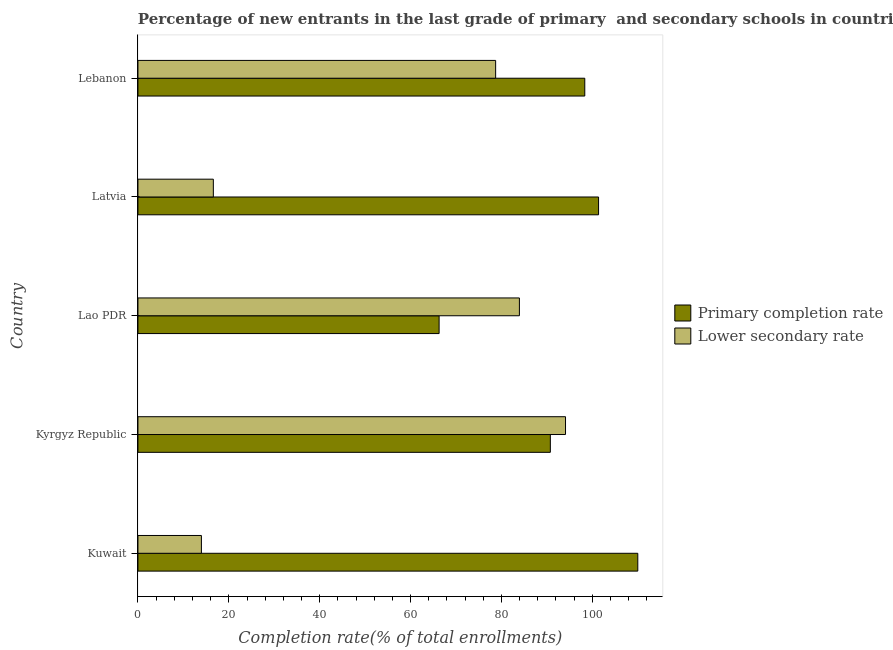How many different coloured bars are there?
Offer a terse response. 2. How many bars are there on the 3rd tick from the top?
Make the answer very short. 2. What is the label of the 2nd group of bars from the top?
Your response must be concise. Latvia. In how many cases, is the number of bars for a given country not equal to the number of legend labels?
Provide a short and direct response. 0. What is the completion rate in primary schools in Latvia?
Ensure brevity in your answer.  101.39. Across all countries, what is the maximum completion rate in primary schools?
Provide a short and direct response. 110.02. Across all countries, what is the minimum completion rate in secondary schools?
Provide a short and direct response. 13.96. In which country was the completion rate in primary schools maximum?
Ensure brevity in your answer.  Kuwait. In which country was the completion rate in primary schools minimum?
Your response must be concise. Lao PDR. What is the total completion rate in secondary schools in the graph?
Give a very brief answer. 287.36. What is the difference between the completion rate in primary schools in Lao PDR and that in Lebanon?
Your answer should be very brief. -32.07. What is the difference between the completion rate in primary schools in Lebanon and the completion rate in secondary schools in Lao PDR?
Provide a succinct answer. 14.39. What is the average completion rate in secondary schools per country?
Your response must be concise. 57.47. What is the difference between the completion rate in secondary schools and completion rate in primary schools in Kyrgyz Republic?
Give a very brief answer. 3.34. What is the ratio of the completion rate in secondary schools in Kuwait to that in Lao PDR?
Provide a succinct answer. 0.17. Is the completion rate in primary schools in Kyrgyz Republic less than that in Lao PDR?
Keep it short and to the point. No. Is the difference between the completion rate in secondary schools in Kuwait and Lebanon greater than the difference between the completion rate in primary schools in Kuwait and Lebanon?
Offer a terse response. No. What is the difference between the highest and the second highest completion rate in primary schools?
Provide a succinct answer. 8.63. What is the difference between the highest and the lowest completion rate in secondary schools?
Keep it short and to the point. 80.15. In how many countries, is the completion rate in primary schools greater than the average completion rate in primary schools taken over all countries?
Your answer should be very brief. 3. What does the 2nd bar from the top in Kuwait represents?
Your answer should be very brief. Primary completion rate. What does the 1st bar from the bottom in Latvia represents?
Give a very brief answer. Primary completion rate. Are the values on the major ticks of X-axis written in scientific E-notation?
Ensure brevity in your answer.  No. Where does the legend appear in the graph?
Ensure brevity in your answer.  Center right. How many legend labels are there?
Your answer should be very brief. 2. What is the title of the graph?
Offer a terse response. Percentage of new entrants in the last grade of primary  and secondary schools in countries. Does "Highest 10% of population" appear as one of the legend labels in the graph?
Your answer should be very brief. No. What is the label or title of the X-axis?
Your answer should be compact. Completion rate(% of total enrollments). What is the label or title of the Y-axis?
Ensure brevity in your answer.  Country. What is the Completion rate(% of total enrollments) in Primary completion rate in Kuwait?
Your answer should be very brief. 110.02. What is the Completion rate(% of total enrollments) in Lower secondary rate in Kuwait?
Your response must be concise. 13.96. What is the Completion rate(% of total enrollments) in Primary completion rate in Kyrgyz Republic?
Keep it short and to the point. 90.77. What is the Completion rate(% of total enrollments) of Lower secondary rate in Kyrgyz Republic?
Keep it short and to the point. 94.11. What is the Completion rate(% of total enrollments) of Primary completion rate in Lao PDR?
Your answer should be compact. 66.29. What is the Completion rate(% of total enrollments) of Lower secondary rate in Lao PDR?
Provide a short and direct response. 83.96. What is the Completion rate(% of total enrollments) in Primary completion rate in Latvia?
Offer a very short reply. 101.39. What is the Completion rate(% of total enrollments) of Lower secondary rate in Latvia?
Your answer should be very brief. 16.59. What is the Completion rate(% of total enrollments) of Primary completion rate in Lebanon?
Offer a very short reply. 98.35. What is the Completion rate(% of total enrollments) of Lower secondary rate in Lebanon?
Keep it short and to the point. 78.73. Across all countries, what is the maximum Completion rate(% of total enrollments) in Primary completion rate?
Offer a terse response. 110.02. Across all countries, what is the maximum Completion rate(% of total enrollments) of Lower secondary rate?
Provide a succinct answer. 94.11. Across all countries, what is the minimum Completion rate(% of total enrollments) of Primary completion rate?
Make the answer very short. 66.29. Across all countries, what is the minimum Completion rate(% of total enrollments) in Lower secondary rate?
Ensure brevity in your answer.  13.96. What is the total Completion rate(% of total enrollments) in Primary completion rate in the graph?
Ensure brevity in your answer.  466.81. What is the total Completion rate(% of total enrollments) in Lower secondary rate in the graph?
Keep it short and to the point. 287.36. What is the difference between the Completion rate(% of total enrollments) in Primary completion rate in Kuwait and that in Kyrgyz Republic?
Your answer should be compact. 19.25. What is the difference between the Completion rate(% of total enrollments) of Lower secondary rate in Kuwait and that in Kyrgyz Republic?
Provide a succinct answer. -80.15. What is the difference between the Completion rate(% of total enrollments) of Primary completion rate in Kuwait and that in Lao PDR?
Offer a terse response. 43.73. What is the difference between the Completion rate(% of total enrollments) in Lower secondary rate in Kuwait and that in Lao PDR?
Provide a short and direct response. -70. What is the difference between the Completion rate(% of total enrollments) of Primary completion rate in Kuwait and that in Latvia?
Give a very brief answer. 8.63. What is the difference between the Completion rate(% of total enrollments) in Lower secondary rate in Kuwait and that in Latvia?
Offer a terse response. -2.63. What is the difference between the Completion rate(% of total enrollments) in Primary completion rate in Kuwait and that in Lebanon?
Your answer should be very brief. 11.67. What is the difference between the Completion rate(% of total enrollments) in Lower secondary rate in Kuwait and that in Lebanon?
Provide a succinct answer. -64.76. What is the difference between the Completion rate(% of total enrollments) in Primary completion rate in Kyrgyz Republic and that in Lao PDR?
Your answer should be compact. 24.48. What is the difference between the Completion rate(% of total enrollments) in Lower secondary rate in Kyrgyz Republic and that in Lao PDR?
Your response must be concise. 10.15. What is the difference between the Completion rate(% of total enrollments) in Primary completion rate in Kyrgyz Republic and that in Latvia?
Give a very brief answer. -10.62. What is the difference between the Completion rate(% of total enrollments) of Lower secondary rate in Kyrgyz Republic and that in Latvia?
Provide a short and direct response. 77.52. What is the difference between the Completion rate(% of total enrollments) in Primary completion rate in Kyrgyz Republic and that in Lebanon?
Provide a short and direct response. -7.58. What is the difference between the Completion rate(% of total enrollments) of Lower secondary rate in Kyrgyz Republic and that in Lebanon?
Keep it short and to the point. 15.38. What is the difference between the Completion rate(% of total enrollments) of Primary completion rate in Lao PDR and that in Latvia?
Your answer should be very brief. -35.1. What is the difference between the Completion rate(% of total enrollments) of Lower secondary rate in Lao PDR and that in Latvia?
Make the answer very short. 67.37. What is the difference between the Completion rate(% of total enrollments) of Primary completion rate in Lao PDR and that in Lebanon?
Keep it short and to the point. -32.07. What is the difference between the Completion rate(% of total enrollments) in Lower secondary rate in Lao PDR and that in Lebanon?
Your response must be concise. 5.23. What is the difference between the Completion rate(% of total enrollments) of Primary completion rate in Latvia and that in Lebanon?
Offer a very short reply. 3.03. What is the difference between the Completion rate(% of total enrollments) in Lower secondary rate in Latvia and that in Lebanon?
Provide a short and direct response. -62.13. What is the difference between the Completion rate(% of total enrollments) of Primary completion rate in Kuwait and the Completion rate(% of total enrollments) of Lower secondary rate in Kyrgyz Republic?
Your answer should be very brief. 15.91. What is the difference between the Completion rate(% of total enrollments) in Primary completion rate in Kuwait and the Completion rate(% of total enrollments) in Lower secondary rate in Lao PDR?
Make the answer very short. 26.06. What is the difference between the Completion rate(% of total enrollments) in Primary completion rate in Kuwait and the Completion rate(% of total enrollments) in Lower secondary rate in Latvia?
Keep it short and to the point. 93.43. What is the difference between the Completion rate(% of total enrollments) in Primary completion rate in Kuwait and the Completion rate(% of total enrollments) in Lower secondary rate in Lebanon?
Provide a succinct answer. 31.29. What is the difference between the Completion rate(% of total enrollments) in Primary completion rate in Kyrgyz Republic and the Completion rate(% of total enrollments) in Lower secondary rate in Lao PDR?
Provide a short and direct response. 6.81. What is the difference between the Completion rate(% of total enrollments) of Primary completion rate in Kyrgyz Republic and the Completion rate(% of total enrollments) of Lower secondary rate in Latvia?
Keep it short and to the point. 74.18. What is the difference between the Completion rate(% of total enrollments) of Primary completion rate in Kyrgyz Republic and the Completion rate(% of total enrollments) of Lower secondary rate in Lebanon?
Offer a very short reply. 12.04. What is the difference between the Completion rate(% of total enrollments) of Primary completion rate in Lao PDR and the Completion rate(% of total enrollments) of Lower secondary rate in Latvia?
Your response must be concise. 49.69. What is the difference between the Completion rate(% of total enrollments) in Primary completion rate in Lao PDR and the Completion rate(% of total enrollments) in Lower secondary rate in Lebanon?
Keep it short and to the point. -12.44. What is the difference between the Completion rate(% of total enrollments) of Primary completion rate in Latvia and the Completion rate(% of total enrollments) of Lower secondary rate in Lebanon?
Offer a terse response. 22.66. What is the average Completion rate(% of total enrollments) of Primary completion rate per country?
Offer a very short reply. 93.36. What is the average Completion rate(% of total enrollments) in Lower secondary rate per country?
Give a very brief answer. 57.47. What is the difference between the Completion rate(% of total enrollments) in Primary completion rate and Completion rate(% of total enrollments) in Lower secondary rate in Kuwait?
Provide a succinct answer. 96.05. What is the difference between the Completion rate(% of total enrollments) of Primary completion rate and Completion rate(% of total enrollments) of Lower secondary rate in Kyrgyz Republic?
Your answer should be compact. -3.34. What is the difference between the Completion rate(% of total enrollments) of Primary completion rate and Completion rate(% of total enrollments) of Lower secondary rate in Lao PDR?
Your response must be concise. -17.68. What is the difference between the Completion rate(% of total enrollments) of Primary completion rate and Completion rate(% of total enrollments) of Lower secondary rate in Latvia?
Your answer should be very brief. 84.79. What is the difference between the Completion rate(% of total enrollments) of Primary completion rate and Completion rate(% of total enrollments) of Lower secondary rate in Lebanon?
Ensure brevity in your answer.  19.62. What is the ratio of the Completion rate(% of total enrollments) of Primary completion rate in Kuwait to that in Kyrgyz Republic?
Provide a short and direct response. 1.21. What is the ratio of the Completion rate(% of total enrollments) in Lower secondary rate in Kuwait to that in Kyrgyz Republic?
Make the answer very short. 0.15. What is the ratio of the Completion rate(% of total enrollments) in Primary completion rate in Kuwait to that in Lao PDR?
Make the answer very short. 1.66. What is the ratio of the Completion rate(% of total enrollments) in Lower secondary rate in Kuwait to that in Lao PDR?
Ensure brevity in your answer.  0.17. What is the ratio of the Completion rate(% of total enrollments) in Primary completion rate in Kuwait to that in Latvia?
Make the answer very short. 1.09. What is the ratio of the Completion rate(% of total enrollments) in Lower secondary rate in Kuwait to that in Latvia?
Your answer should be very brief. 0.84. What is the ratio of the Completion rate(% of total enrollments) in Primary completion rate in Kuwait to that in Lebanon?
Provide a short and direct response. 1.12. What is the ratio of the Completion rate(% of total enrollments) in Lower secondary rate in Kuwait to that in Lebanon?
Your answer should be very brief. 0.18. What is the ratio of the Completion rate(% of total enrollments) in Primary completion rate in Kyrgyz Republic to that in Lao PDR?
Make the answer very short. 1.37. What is the ratio of the Completion rate(% of total enrollments) in Lower secondary rate in Kyrgyz Republic to that in Lao PDR?
Your answer should be very brief. 1.12. What is the ratio of the Completion rate(% of total enrollments) of Primary completion rate in Kyrgyz Republic to that in Latvia?
Make the answer very short. 0.9. What is the ratio of the Completion rate(% of total enrollments) of Lower secondary rate in Kyrgyz Republic to that in Latvia?
Provide a short and direct response. 5.67. What is the ratio of the Completion rate(% of total enrollments) in Primary completion rate in Kyrgyz Republic to that in Lebanon?
Keep it short and to the point. 0.92. What is the ratio of the Completion rate(% of total enrollments) of Lower secondary rate in Kyrgyz Republic to that in Lebanon?
Your response must be concise. 1.2. What is the ratio of the Completion rate(% of total enrollments) of Primary completion rate in Lao PDR to that in Latvia?
Your answer should be very brief. 0.65. What is the ratio of the Completion rate(% of total enrollments) in Lower secondary rate in Lao PDR to that in Latvia?
Give a very brief answer. 5.06. What is the ratio of the Completion rate(% of total enrollments) in Primary completion rate in Lao PDR to that in Lebanon?
Your response must be concise. 0.67. What is the ratio of the Completion rate(% of total enrollments) of Lower secondary rate in Lao PDR to that in Lebanon?
Your answer should be compact. 1.07. What is the ratio of the Completion rate(% of total enrollments) of Primary completion rate in Latvia to that in Lebanon?
Make the answer very short. 1.03. What is the ratio of the Completion rate(% of total enrollments) in Lower secondary rate in Latvia to that in Lebanon?
Your response must be concise. 0.21. What is the difference between the highest and the second highest Completion rate(% of total enrollments) of Primary completion rate?
Offer a very short reply. 8.63. What is the difference between the highest and the second highest Completion rate(% of total enrollments) in Lower secondary rate?
Make the answer very short. 10.15. What is the difference between the highest and the lowest Completion rate(% of total enrollments) of Primary completion rate?
Offer a terse response. 43.73. What is the difference between the highest and the lowest Completion rate(% of total enrollments) of Lower secondary rate?
Provide a short and direct response. 80.15. 